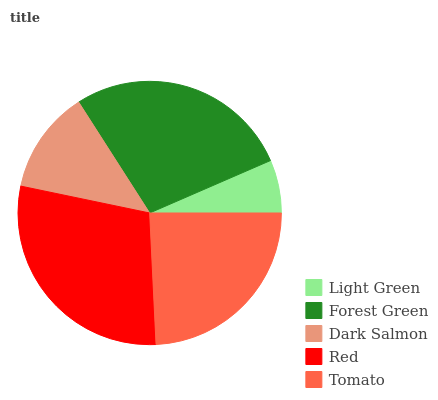Is Light Green the minimum?
Answer yes or no. Yes. Is Red the maximum?
Answer yes or no. Yes. Is Forest Green the minimum?
Answer yes or no. No. Is Forest Green the maximum?
Answer yes or no. No. Is Forest Green greater than Light Green?
Answer yes or no. Yes. Is Light Green less than Forest Green?
Answer yes or no. Yes. Is Light Green greater than Forest Green?
Answer yes or no. No. Is Forest Green less than Light Green?
Answer yes or no. No. Is Tomato the high median?
Answer yes or no. Yes. Is Tomato the low median?
Answer yes or no. Yes. Is Dark Salmon the high median?
Answer yes or no. No. Is Forest Green the low median?
Answer yes or no. No. 